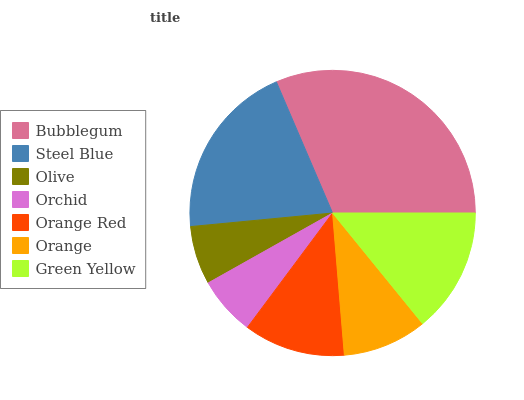Is Olive the minimum?
Answer yes or no. Yes. Is Bubblegum the maximum?
Answer yes or no. Yes. Is Steel Blue the minimum?
Answer yes or no. No. Is Steel Blue the maximum?
Answer yes or no. No. Is Bubblegum greater than Steel Blue?
Answer yes or no. Yes. Is Steel Blue less than Bubblegum?
Answer yes or no. Yes. Is Steel Blue greater than Bubblegum?
Answer yes or no. No. Is Bubblegum less than Steel Blue?
Answer yes or no. No. Is Orange Red the high median?
Answer yes or no. Yes. Is Orange Red the low median?
Answer yes or no. Yes. Is Olive the high median?
Answer yes or no. No. Is Olive the low median?
Answer yes or no. No. 